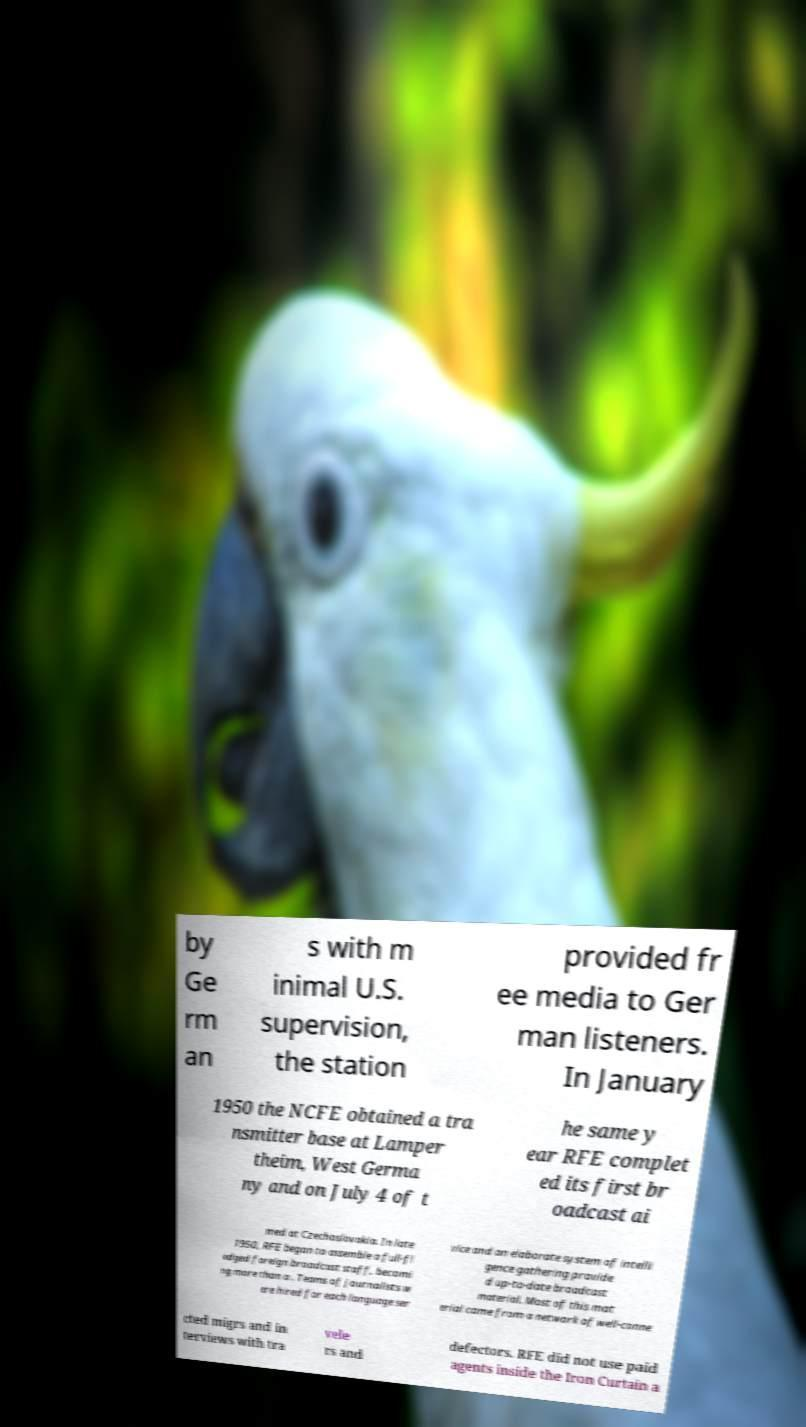Can you accurately transcribe the text from the provided image for me? by Ge rm an s with m inimal U.S. supervision, the station provided fr ee media to Ger man listeners. In January 1950 the NCFE obtained a tra nsmitter base at Lamper theim, West Germa ny and on July 4 of t he same y ear RFE complet ed its first br oadcast ai med at Czechoslovakia. In late 1950, RFE began to assemble a full-fl edged foreign broadcast staff, becomi ng more than a . Teams of journalists w ere hired for each language ser vice and an elaborate system of intelli gence gathering provide d up-to-date broadcast material. Most of this mat erial came from a network of well-conne cted migrs and in terviews with tra vele rs and defectors. RFE did not use paid agents inside the Iron Curtain a 